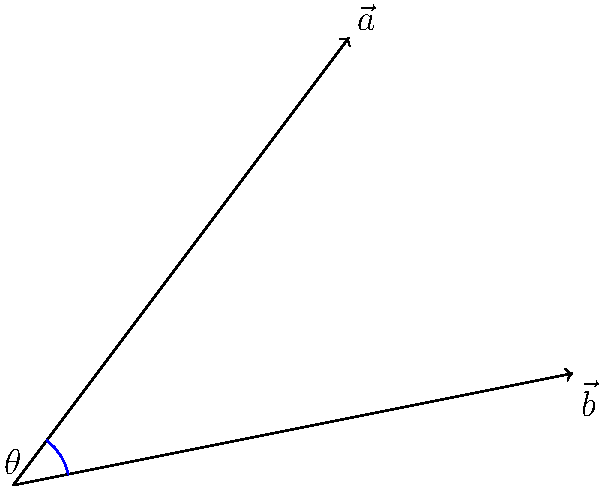Given two vectors $\vec{a} = (3, 4)$ and $\vec{b} = (5, 1)$ in 2D space, calculate the angle $\theta$ between them. Round your answer to the nearest degree. To find the angle between two vectors, we can use the dot product formula:

$$\cos \theta = \frac{\vec{a} \cdot \vec{b}}{|\vec{a}||\vec{b}|}$$

Step 1: Calculate the dot product $\vec{a} \cdot \vec{b}$
$$\vec{a} \cdot \vec{b} = (3 \times 5) + (4 \times 1) = 15 + 4 = 19$$

Step 2: Calculate the magnitudes of the vectors
$$|\vec{a}| = \sqrt{3^2 + 4^2} = \sqrt{9 + 16} = \sqrt{25} = 5$$
$$|\vec{b}| = \sqrt{5^2 + 1^2} = \sqrt{25 + 1} = \sqrt{26}$$

Step 3: Apply the dot product formula
$$\cos \theta = \frac{19}{5\sqrt{26}}$$

Step 4: Take the inverse cosine (arccos) of both sides
$$\theta = \arccos\left(\frac{19}{5\sqrt{26}}\right)$$

Step 5: Calculate the result and round to the nearest degree
$$\theta \approx 44.42^\circ \approx 44^\circ$$
Answer: 44° 